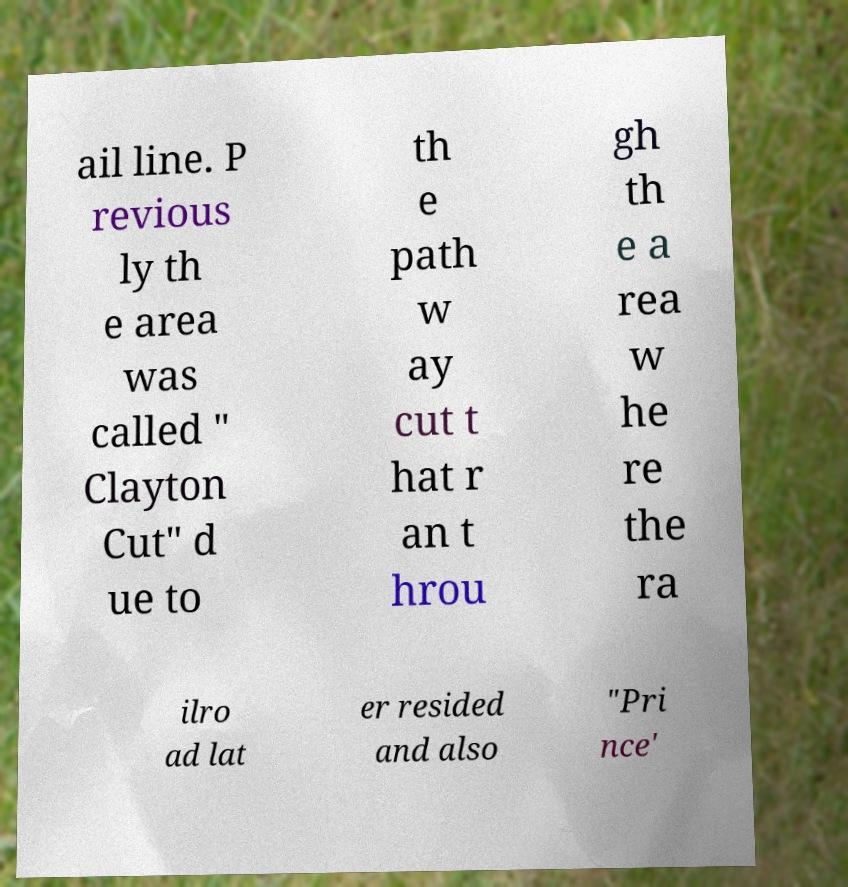There's text embedded in this image that I need extracted. Can you transcribe it verbatim? ail line. P revious ly th e area was called " Clayton Cut" d ue to th e path w ay cut t hat r an t hrou gh th e a rea w he re the ra ilro ad lat er resided and also "Pri nce' 